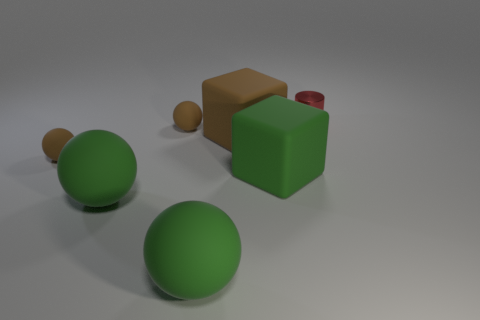Add 3 rubber cylinders. How many objects exist? 10 Subtract all cylinders. How many objects are left? 6 Add 2 tiny red metal cylinders. How many tiny red metal cylinders are left? 3 Add 2 brown balls. How many brown balls exist? 4 Subtract all green blocks. How many blocks are left? 1 Subtract 0 purple cylinders. How many objects are left? 7 Subtract 1 cubes. How many cubes are left? 1 Subtract all cyan balls. Subtract all yellow blocks. How many balls are left? 4 Subtract all gray blocks. How many blue balls are left? 0 Subtract all big yellow matte cubes. Subtract all large green things. How many objects are left? 4 